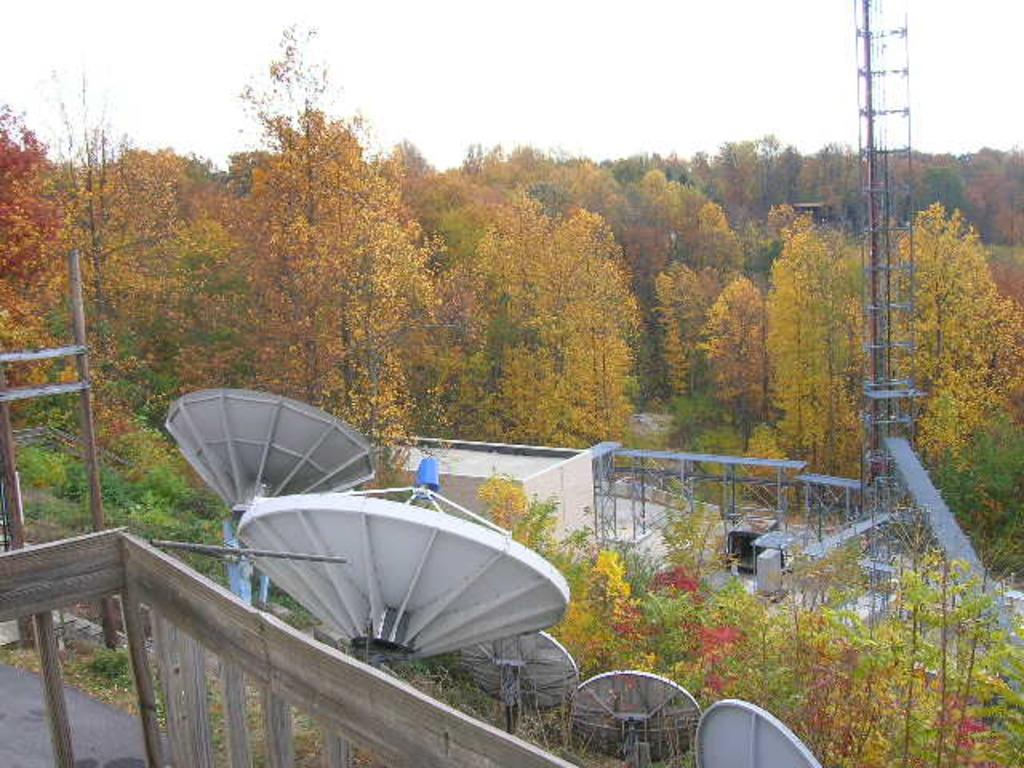What structures can be seen in the image? There are antennas and cell towers in the image. What type of vegetation is present in the image? There are trees, plants, and grass in the image. What is the ground surface like in the image? There is a road in the image. What part of the natural environment is visible in the image? The sky is visible in the image. How far away is the sofa from the trees in the image? There is no sofa present in the image. What type of tin can be seen in the image? There is no tin present in the image. 